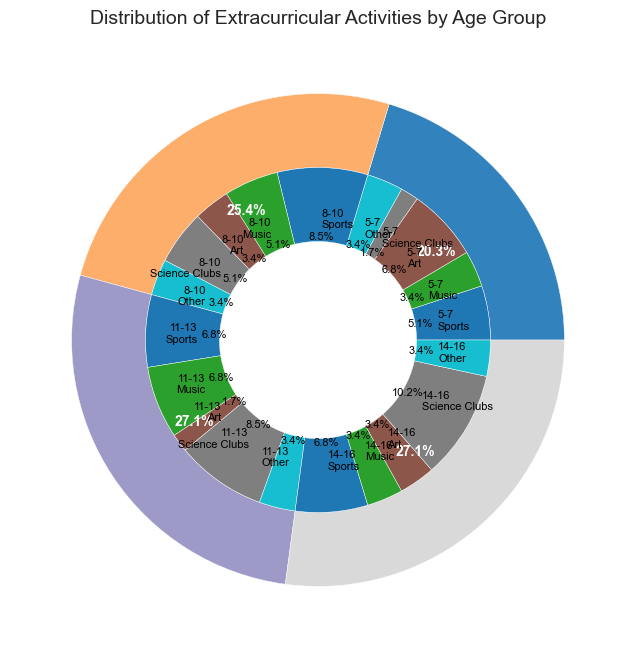What is the most popular activity for children aged 8-10? The pie chart for children aged 8-10 shows that the largest segment is for Sports, which indicates it is the most popular activity for this age group.
Answer: Sports What percentage of children aged 5-7 are involved in artistic activities, such as Art? The pie chart segment for Art in the 5-7 age group is 20%.
Answer: 20% Which age group dedicates the largest percentage to Science Clubs? The pie chart for the 14-16 age group shows that 30% are involved in Science Clubs, which is the largest compared to the other age groups.
Answer: 14-16 Compare the percentage of children participating in Music between the age groups 11-13 and 8-10. The pie chart for the 11-13 age group shows 20% are involved in Music, whereas the 8-10 age group shows 15%. Therefore, 11-13 has a higher percentage.
Answer: 11-13 Which age group has the smallest proportion of Other activities? The 5-7, 8-10, 11-13, and 14-16 age groups each have a 10% segment dedicated to Other activities. This indicates that all age groups have the same proportion for Other activities.
Answer: All are equal How does the percentage of children engaging in Sports change from age group 5-7 to age group 8-10? The percentage of children participating in Sports increases from 15% in the 5-7 age group to 25% in the 8-10 age group.
Answer: It increases Sum the percentages of children aged 5-7 participating in Music and Science Clubs. The percentage of children aged 5-7 involved in Music is 10%, and in Science Clubs is 5%. Summing these gives 10% + 5% = 15%.
Answer: 15% Compare the total percentage of children participating in Art across all age groups. Which age group has the least participation? The pie charts show that: 5-7 has 20% in Art, 8-10 has 10%, 11-13 has 5%, and 14-16 has 10%. Thus, the 11-13 age group has the least participation in Art.
Answer: 11-13 How many percentage points more children aged 14-16 participate in Science Clubs than children aged 5-7? The pie chart shows 14-16 age group’s participation in Science Clubs is 30%, and for 5-7, it’s 5%. The difference is 30% - 5% = 25 percentage points.
Answer: 25 percentage points What is the proportion of children in the 11-13 age group who are involved in Music compared to all other activities in the same age group? The 11-13 age group’s Music percentage is 20%. The other activities account for 20% + 5% + 25% + 10% = 60%. Therefore, the proportion of Music is 20% / 80% = 0.25 or 25%.
Answer: 25% 